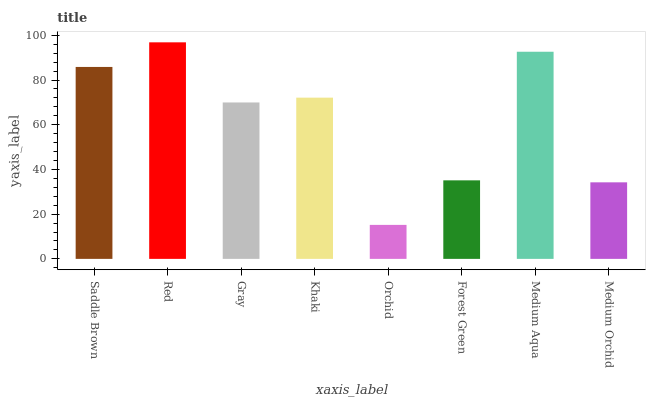Is Orchid the minimum?
Answer yes or no. Yes. Is Red the maximum?
Answer yes or no. Yes. Is Gray the minimum?
Answer yes or no. No. Is Gray the maximum?
Answer yes or no. No. Is Red greater than Gray?
Answer yes or no. Yes. Is Gray less than Red?
Answer yes or no. Yes. Is Gray greater than Red?
Answer yes or no. No. Is Red less than Gray?
Answer yes or no. No. Is Khaki the high median?
Answer yes or no. Yes. Is Gray the low median?
Answer yes or no. Yes. Is Orchid the high median?
Answer yes or no. No. Is Khaki the low median?
Answer yes or no. No. 